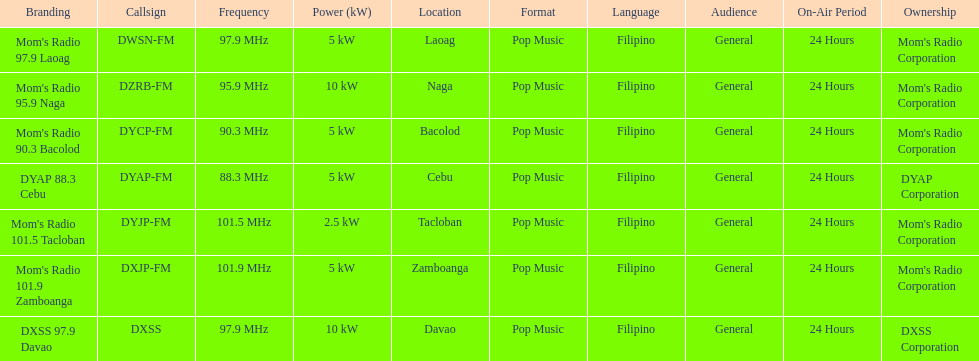What is the only radio station with a frequency below 90 mhz? DYAP 88.3 Cebu. 